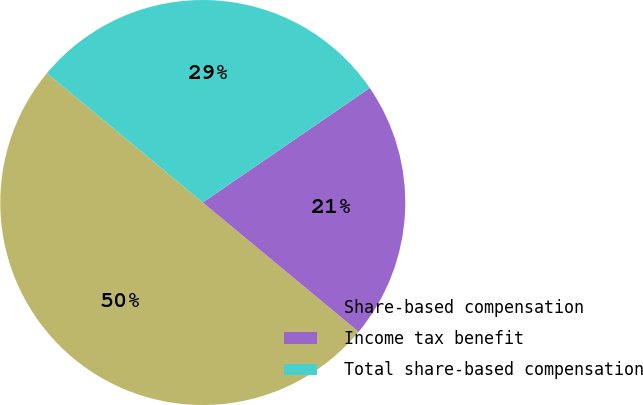<chart> <loc_0><loc_0><loc_500><loc_500><pie_chart><fcel>Share-based compensation<fcel>Income tax benefit<fcel>Total share-based compensation<nl><fcel>50.0%<fcel>20.59%<fcel>29.41%<nl></chart> 